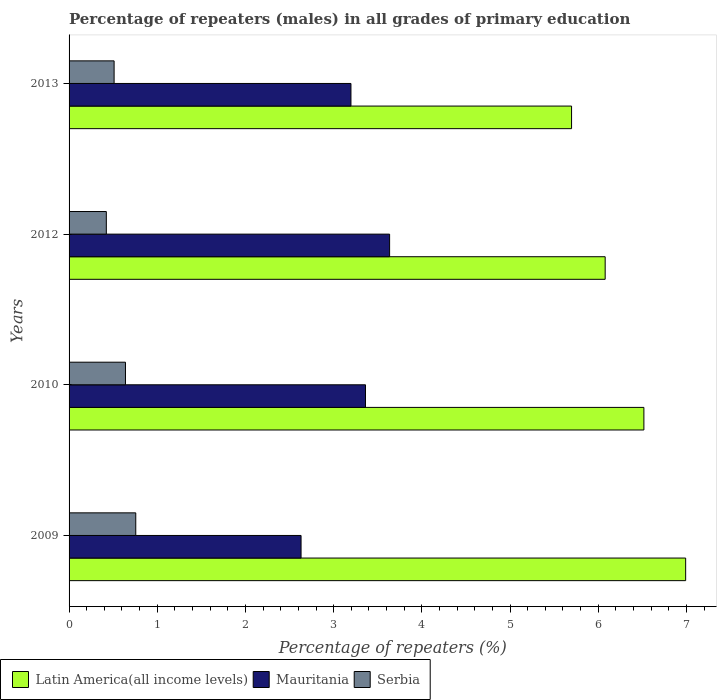How many different coloured bars are there?
Provide a short and direct response. 3. Are the number of bars on each tick of the Y-axis equal?
Keep it short and to the point. Yes. How many bars are there on the 3rd tick from the top?
Keep it short and to the point. 3. In how many cases, is the number of bars for a given year not equal to the number of legend labels?
Offer a terse response. 0. What is the percentage of repeaters (males) in Latin America(all income levels) in 2012?
Offer a terse response. 6.08. Across all years, what is the maximum percentage of repeaters (males) in Serbia?
Provide a succinct answer. 0.76. Across all years, what is the minimum percentage of repeaters (males) in Latin America(all income levels)?
Your answer should be compact. 5.7. In which year was the percentage of repeaters (males) in Serbia minimum?
Provide a short and direct response. 2012. What is the total percentage of repeaters (males) in Latin America(all income levels) in the graph?
Offer a terse response. 25.29. What is the difference between the percentage of repeaters (males) in Latin America(all income levels) in 2010 and that in 2012?
Give a very brief answer. 0.44. What is the difference between the percentage of repeaters (males) in Serbia in 2009 and the percentage of repeaters (males) in Mauritania in 2013?
Give a very brief answer. -2.44. What is the average percentage of repeaters (males) in Serbia per year?
Keep it short and to the point. 0.58. In the year 2013, what is the difference between the percentage of repeaters (males) in Latin America(all income levels) and percentage of repeaters (males) in Mauritania?
Your answer should be compact. 2.5. What is the ratio of the percentage of repeaters (males) in Latin America(all income levels) in 2009 to that in 2013?
Make the answer very short. 1.23. What is the difference between the highest and the second highest percentage of repeaters (males) in Serbia?
Your answer should be very brief. 0.12. What is the difference between the highest and the lowest percentage of repeaters (males) in Mauritania?
Keep it short and to the point. 1. In how many years, is the percentage of repeaters (males) in Latin America(all income levels) greater than the average percentage of repeaters (males) in Latin America(all income levels) taken over all years?
Ensure brevity in your answer.  2. What does the 1st bar from the top in 2010 represents?
Your answer should be compact. Serbia. What does the 3rd bar from the bottom in 2013 represents?
Your answer should be compact. Serbia. Are all the bars in the graph horizontal?
Ensure brevity in your answer.  Yes. How many years are there in the graph?
Provide a short and direct response. 4. What is the difference between two consecutive major ticks on the X-axis?
Provide a succinct answer. 1. Does the graph contain grids?
Provide a succinct answer. No. Where does the legend appear in the graph?
Your response must be concise. Bottom left. What is the title of the graph?
Give a very brief answer. Percentage of repeaters (males) in all grades of primary education. What is the label or title of the X-axis?
Offer a very short reply. Percentage of repeaters (%). What is the label or title of the Y-axis?
Ensure brevity in your answer.  Years. What is the Percentage of repeaters (%) in Latin America(all income levels) in 2009?
Offer a terse response. 6.99. What is the Percentage of repeaters (%) of Mauritania in 2009?
Ensure brevity in your answer.  2.63. What is the Percentage of repeaters (%) of Serbia in 2009?
Your answer should be very brief. 0.76. What is the Percentage of repeaters (%) of Latin America(all income levels) in 2010?
Your response must be concise. 6.52. What is the Percentage of repeaters (%) of Mauritania in 2010?
Your answer should be very brief. 3.36. What is the Percentage of repeaters (%) in Serbia in 2010?
Your response must be concise. 0.64. What is the Percentage of repeaters (%) in Latin America(all income levels) in 2012?
Offer a terse response. 6.08. What is the Percentage of repeaters (%) of Mauritania in 2012?
Your answer should be compact. 3.63. What is the Percentage of repeaters (%) in Serbia in 2012?
Provide a short and direct response. 0.42. What is the Percentage of repeaters (%) of Latin America(all income levels) in 2013?
Make the answer very short. 5.7. What is the Percentage of repeaters (%) of Mauritania in 2013?
Your response must be concise. 3.2. What is the Percentage of repeaters (%) in Serbia in 2013?
Offer a terse response. 0.51. Across all years, what is the maximum Percentage of repeaters (%) in Latin America(all income levels)?
Provide a short and direct response. 6.99. Across all years, what is the maximum Percentage of repeaters (%) in Mauritania?
Give a very brief answer. 3.63. Across all years, what is the maximum Percentage of repeaters (%) in Serbia?
Offer a very short reply. 0.76. Across all years, what is the minimum Percentage of repeaters (%) in Latin America(all income levels)?
Provide a succinct answer. 5.7. Across all years, what is the minimum Percentage of repeaters (%) of Mauritania?
Keep it short and to the point. 2.63. Across all years, what is the minimum Percentage of repeaters (%) in Serbia?
Ensure brevity in your answer.  0.42. What is the total Percentage of repeaters (%) of Latin America(all income levels) in the graph?
Ensure brevity in your answer.  25.29. What is the total Percentage of repeaters (%) of Mauritania in the graph?
Your answer should be compact. 12.82. What is the total Percentage of repeaters (%) of Serbia in the graph?
Your answer should be compact. 2.33. What is the difference between the Percentage of repeaters (%) in Latin America(all income levels) in 2009 and that in 2010?
Your answer should be very brief. 0.47. What is the difference between the Percentage of repeaters (%) of Mauritania in 2009 and that in 2010?
Offer a terse response. -0.73. What is the difference between the Percentage of repeaters (%) of Serbia in 2009 and that in 2010?
Provide a succinct answer. 0.12. What is the difference between the Percentage of repeaters (%) in Latin America(all income levels) in 2009 and that in 2012?
Your response must be concise. 0.91. What is the difference between the Percentage of repeaters (%) in Mauritania in 2009 and that in 2012?
Ensure brevity in your answer.  -1. What is the difference between the Percentage of repeaters (%) in Serbia in 2009 and that in 2012?
Provide a succinct answer. 0.33. What is the difference between the Percentage of repeaters (%) of Latin America(all income levels) in 2009 and that in 2013?
Your response must be concise. 1.29. What is the difference between the Percentage of repeaters (%) of Mauritania in 2009 and that in 2013?
Provide a short and direct response. -0.57. What is the difference between the Percentage of repeaters (%) in Serbia in 2009 and that in 2013?
Provide a succinct answer. 0.25. What is the difference between the Percentage of repeaters (%) in Latin America(all income levels) in 2010 and that in 2012?
Provide a short and direct response. 0.44. What is the difference between the Percentage of repeaters (%) in Mauritania in 2010 and that in 2012?
Your answer should be compact. -0.27. What is the difference between the Percentage of repeaters (%) in Serbia in 2010 and that in 2012?
Keep it short and to the point. 0.22. What is the difference between the Percentage of repeaters (%) of Latin America(all income levels) in 2010 and that in 2013?
Provide a short and direct response. 0.82. What is the difference between the Percentage of repeaters (%) in Mauritania in 2010 and that in 2013?
Provide a succinct answer. 0.17. What is the difference between the Percentage of repeaters (%) of Serbia in 2010 and that in 2013?
Your answer should be very brief. 0.13. What is the difference between the Percentage of repeaters (%) in Latin America(all income levels) in 2012 and that in 2013?
Make the answer very short. 0.38. What is the difference between the Percentage of repeaters (%) in Mauritania in 2012 and that in 2013?
Your response must be concise. 0.44. What is the difference between the Percentage of repeaters (%) in Serbia in 2012 and that in 2013?
Your response must be concise. -0.09. What is the difference between the Percentage of repeaters (%) of Latin America(all income levels) in 2009 and the Percentage of repeaters (%) of Mauritania in 2010?
Ensure brevity in your answer.  3.63. What is the difference between the Percentage of repeaters (%) of Latin America(all income levels) in 2009 and the Percentage of repeaters (%) of Serbia in 2010?
Your answer should be very brief. 6.35. What is the difference between the Percentage of repeaters (%) in Mauritania in 2009 and the Percentage of repeaters (%) in Serbia in 2010?
Offer a very short reply. 1.99. What is the difference between the Percentage of repeaters (%) in Latin America(all income levels) in 2009 and the Percentage of repeaters (%) in Mauritania in 2012?
Your response must be concise. 3.36. What is the difference between the Percentage of repeaters (%) in Latin America(all income levels) in 2009 and the Percentage of repeaters (%) in Serbia in 2012?
Make the answer very short. 6.57. What is the difference between the Percentage of repeaters (%) in Mauritania in 2009 and the Percentage of repeaters (%) in Serbia in 2012?
Offer a very short reply. 2.21. What is the difference between the Percentage of repeaters (%) of Latin America(all income levels) in 2009 and the Percentage of repeaters (%) of Mauritania in 2013?
Provide a short and direct response. 3.8. What is the difference between the Percentage of repeaters (%) in Latin America(all income levels) in 2009 and the Percentage of repeaters (%) in Serbia in 2013?
Offer a terse response. 6.48. What is the difference between the Percentage of repeaters (%) in Mauritania in 2009 and the Percentage of repeaters (%) in Serbia in 2013?
Ensure brevity in your answer.  2.12. What is the difference between the Percentage of repeaters (%) of Latin America(all income levels) in 2010 and the Percentage of repeaters (%) of Mauritania in 2012?
Provide a succinct answer. 2.88. What is the difference between the Percentage of repeaters (%) in Latin America(all income levels) in 2010 and the Percentage of repeaters (%) in Serbia in 2012?
Provide a short and direct response. 6.1. What is the difference between the Percentage of repeaters (%) of Mauritania in 2010 and the Percentage of repeaters (%) of Serbia in 2012?
Offer a terse response. 2.94. What is the difference between the Percentage of repeaters (%) in Latin America(all income levels) in 2010 and the Percentage of repeaters (%) in Mauritania in 2013?
Ensure brevity in your answer.  3.32. What is the difference between the Percentage of repeaters (%) of Latin America(all income levels) in 2010 and the Percentage of repeaters (%) of Serbia in 2013?
Ensure brevity in your answer.  6.01. What is the difference between the Percentage of repeaters (%) of Mauritania in 2010 and the Percentage of repeaters (%) of Serbia in 2013?
Your response must be concise. 2.85. What is the difference between the Percentage of repeaters (%) in Latin America(all income levels) in 2012 and the Percentage of repeaters (%) in Mauritania in 2013?
Keep it short and to the point. 2.88. What is the difference between the Percentage of repeaters (%) in Latin America(all income levels) in 2012 and the Percentage of repeaters (%) in Serbia in 2013?
Your answer should be compact. 5.57. What is the difference between the Percentage of repeaters (%) in Mauritania in 2012 and the Percentage of repeaters (%) in Serbia in 2013?
Give a very brief answer. 3.12. What is the average Percentage of repeaters (%) in Latin America(all income levels) per year?
Keep it short and to the point. 6.32. What is the average Percentage of repeaters (%) of Mauritania per year?
Your answer should be compact. 3.21. What is the average Percentage of repeaters (%) in Serbia per year?
Your response must be concise. 0.58. In the year 2009, what is the difference between the Percentage of repeaters (%) of Latin America(all income levels) and Percentage of repeaters (%) of Mauritania?
Your answer should be compact. 4.36. In the year 2009, what is the difference between the Percentage of repeaters (%) of Latin America(all income levels) and Percentage of repeaters (%) of Serbia?
Your answer should be compact. 6.24. In the year 2009, what is the difference between the Percentage of repeaters (%) of Mauritania and Percentage of repeaters (%) of Serbia?
Your answer should be very brief. 1.87. In the year 2010, what is the difference between the Percentage of repeaters (%) of Latin America(all income levels) and Percentage of repeaters (%) of Mauritania?
Keep it short and to the point. 3.16. In the year 2010, what is the difference between the Percentage of repeaters (%) of Latin America(all income levels) and Percentage of repeaters (%) of Serbia?
Ensure brevity in your answer.  5.88. In the year 2010, what is the difference between the Percentage of repeaters (%) of Mauritania and Percentage of repeaters (%) of Serbia?
Your answer should be compact. 2.72. In the year 2012, what is the difference between the Percentage of repeaters (%) in Latin America(all income levels) and Percentage of repeaters (%) in Mauritania?
Provide a short and direct response. 2.44. In the year 2012, what is the difference between the Percentage of repeaters (%) of Latin America(all income levels) and Percentage of repeaters (%) of Serbia?
Your response must be concise. 5.66. In the year 2012, what is the difference between the Percentage of repeaters (%) of Mauritania and Percentage of repeaters (%) of Serbia?
Keep it short and to the point. 3.21. In the year 2013, what is the difference between the Percentage of repeaters (%) of Latin America(all income levels) and Percentage of repeaters (%) of Mauritania?
Provide a succinct answer. 2.5. In the year 2013, what is the difference between the Percentage of repeaters (%) of Latin America(all income levels) and Percentage of repeaters (%) of Serbia?
Your response must be concise. 5.19. In the year 2013, what is the difference between the Percentage of repeaters (%) in Mauritania and Percentage of repeaters (%) in Serbia?
Make the answer very short. 2.69. What is the ratio of the Percentage of repeaters (%) of Latin America(all income levels) in 2009 to that in 2010?
Make the answer very short. 1.07. What is the ratio of the Percentage of repeaters (%) of Mauritania in 2009 to that in 2010?
Provide a succinct answer. 0.78. What is the ratio of the Percentage of repeaters (%) of Serbia in 2009 to that in 2010?
Offer a terse response. 1.18. What is the ratio of the Percentage of repeaters (%) in Latin America(all income levels) in 2009 to that in 2012?
Provide a succinct answer. 1.15. What is the ratio of the Percentage of repeaters (%) in Mauritania in 2009 to that in 2012?
Provide a short and direct response. 0.72. What is the ratio of the Percentage of repeaters (%) of Serbia in 2009 to that in 2012?
Keep it short and to the point. 1.79. What is the ratio of the Percentage of repeaters (%) of Latin America(all income levels) in 2009 to that in 2013?
Provide a succinct answer. 1.23. What is the ratio of the Percentage of repeaters (%) in Mauritania in 2009 to that in 2013?
Provide a succinct answer. 0.82. What is the ratio of the Percentage of repeaters (%) of Serbia in 2009 to that in 2013?
Give a very brief answer. 1.48. What is the ratio of the Percentage of repeaters (%) in Latin America(all income levels) in 2010 to that in 2012?
Make the answer very short. 1.07. What is the ratio of the Percentage of repeaters (%) of Mauritania in 2010 to that in 2012?
Your answer should be compact. 0.92. What is the ratio of the Percentage of repeaters (%) of Serbia in 2010 to that in 2012?
Offer a terse response. 1.51. What is the ratio of the Percentage of repeaters (%) of Latin America(all income levels) in 2010 to that in 2013?
Give a very brief answer. 1.14. What is the ratio of the Percentage of repeaters (%) of Mauritania in 2010 to that in 2013?
Your answer should be compact. 1.05. What is the ratio of the Percentage of repeaters (%) in Serbia in 2010 to that in 2013?
Offer a terse response. 1.25. What is the ratio of the Percentage of repeaters (%) in Latin America(all income levels) in 2012 to that in 2013?
Offer a terse response. 1.07. What is the ratio of the Percentage of repeaters (%) in Mauritania in 2012 to that in 2013?
Give a very brief answer. 1.14. What is the ratio of the Percentage of repeaters (%) of Serbia in 2012 to that in 2013?
Offer a very short reply. 0.83. What is the difference between the highest and the second highest Percentage of repeaters (%) of Latin America(all income levels)?
Keep it short and to the point. 0.47. What is the difference between the highest and the second highest Percentage of repeaters (%) in Mauritania?
Provide a short and direct response. 0.27. What is the difference between the highest and the second highest Percentage of repeaters (%) in Serbia?
Make the answer very short. 0.12. What is the difference between the highest and the lowest Percentage of repeaters (%) of Latin America(all income levels)?
Provide a short and direct response. 1.29. What is the difference between the highest and the lowest Percentage of repeaters (%) of Serbia?
Your answer should be compact. 0.33. 